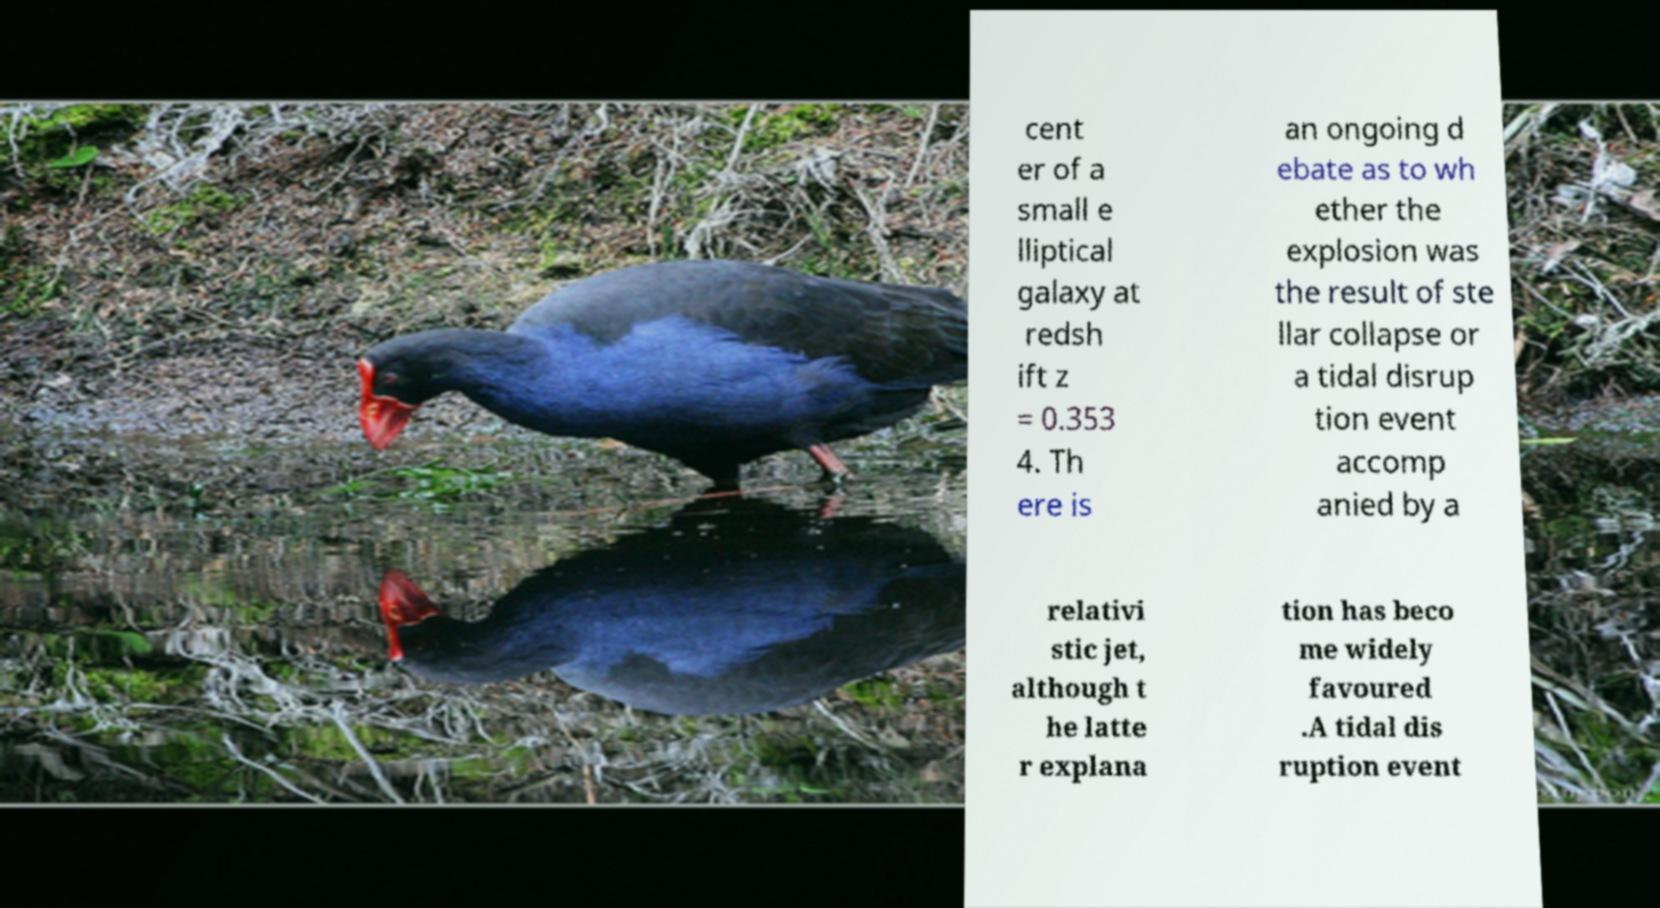There's text embedded in this image that I need extracted. Can you transcribe it verbatim? cent er of a small e lliptical galaxy at redsh ift z = 0.353 4. Th ere is an ongoing d ebate as to wh ether the explosion was the result of ste llar collapse or a tidal disrup tion event accomp anied by a relativi stic jet, although t he latte r explana tion has beco me widely favoured .A tidal dis ruption event 